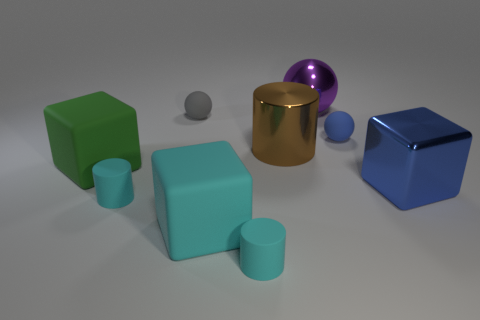Imagine these objects are part of a children's toy set. Describe a game that could be played with them. One game idea could be called 'Balance Builders' where players take turns stacking different objects on top of one another without the structure collapsing. Points are awarded for successfully adding items, with the spheres being tricky additions due to their round surfaces. 